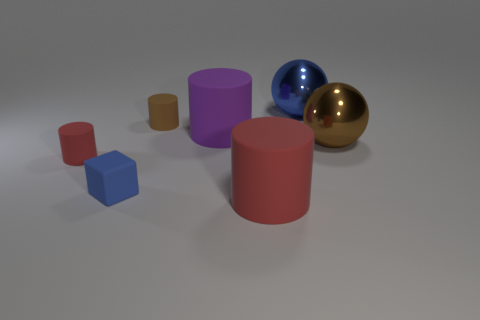Can you describe the lighting in the scene and how it affects the appearance of these objects? The lighting in the scene seems to be diffused, coming from above, with a soft-box-like quality that offers gentle shadows and subtle highlights. It contributes to the realistic appearance of the objects by enhancing their textures and material qualities. The rubber block shows minimal reflections, while the plastics have soft, bright spots, indicating their semi-glossy finish. The ceramic or painted cylinder has a uniform light distribution on its surface. Lastly, the metal spheres boast sharp reflections and distinctive highlights, which emphasize their glossy and smooth surfaces. 